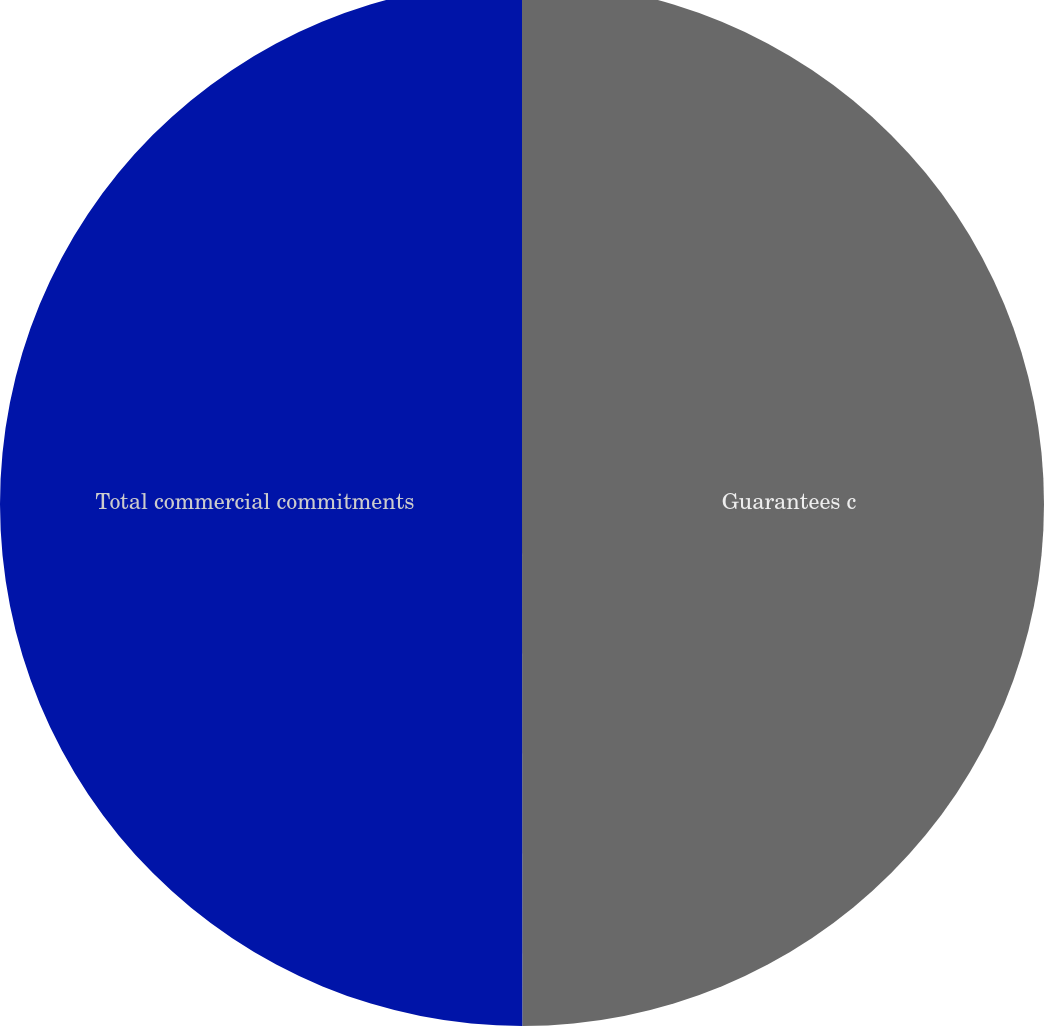Convert chart. <chart><loc_0><loc_0><loc_500><loc_500><pie_chart><fcel>Guarantees c<fcel>Total commercial commitments<nl><fcel>49.99%<fcel>50.01%<nl></chart> 